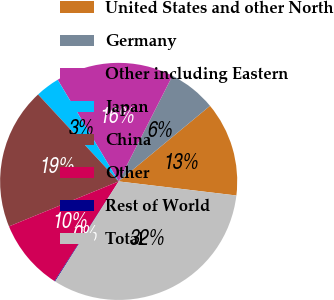Convert chart. <chart><loc_0><loc_0><loc_500><loc_500><pie_chart><fcel>United States and other North<fcel>Germany<fcel>Other including Eastern<fcel>Japan<fcel>China<fcel>Other<fcel>Rest of World<fcel>Total<nl><fcel>12.9%<fcel>6.5%<fcel>16.1%<fcel>3.3%<fcel>19.3%<fcel>9.7%<fcel>0.1%<fcel>32.11%<nl></chart> 